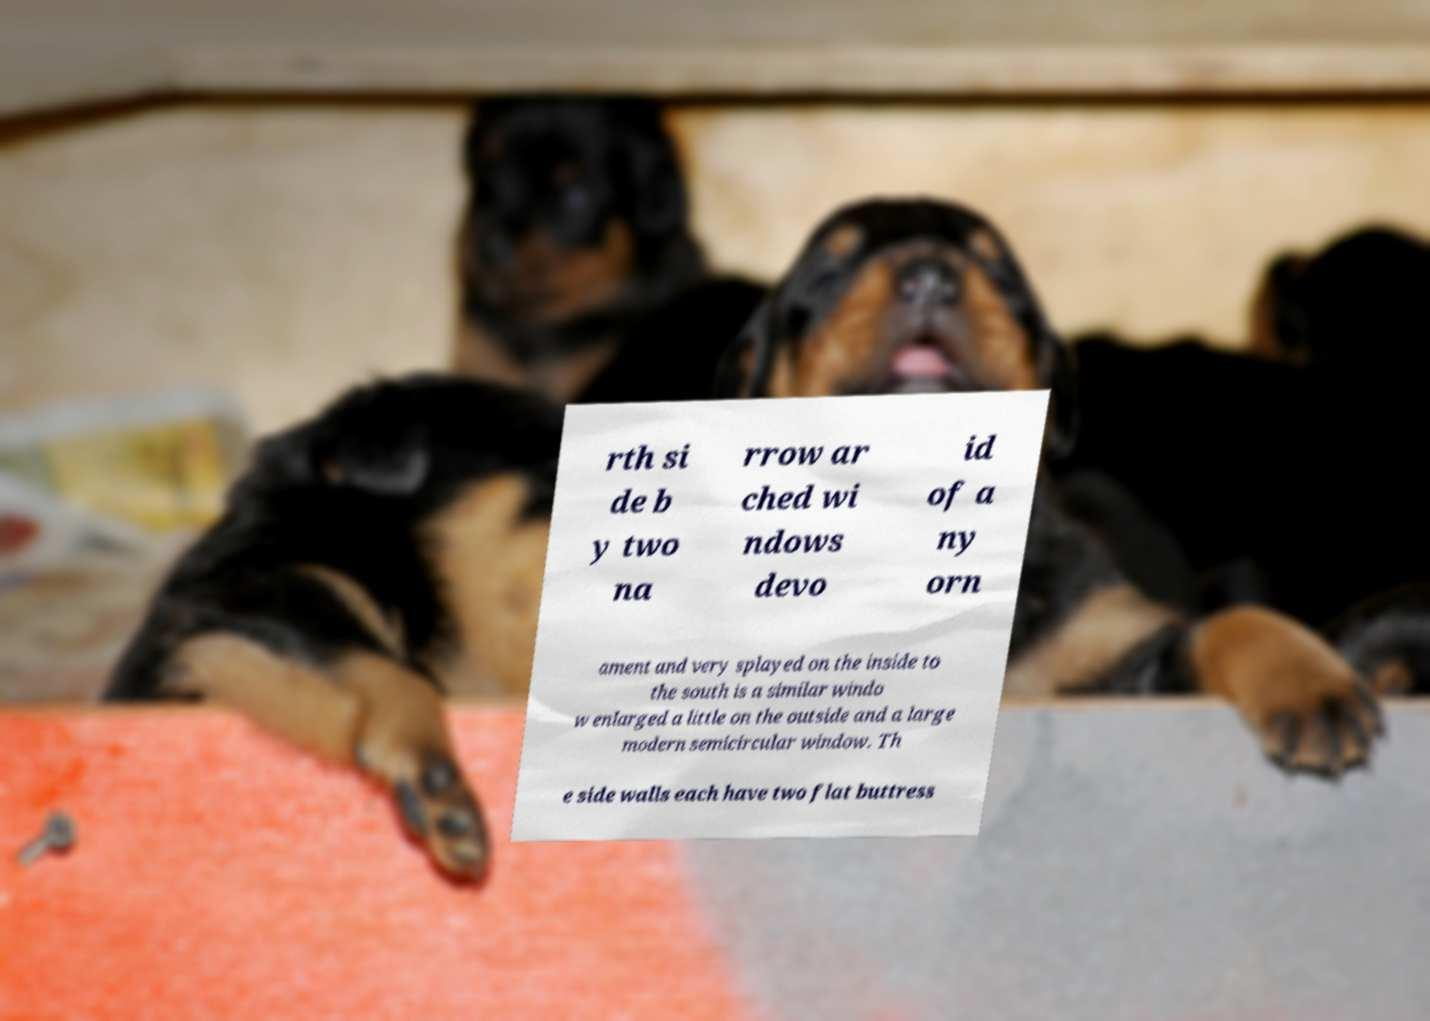I need the written content from this picture converted into text. Can you do that? rth si de b y two na rrow ar ched wi ndows devo id of a ny orn ament and very splayed on the inside to the south is a similar windo w enlarged a little on the outside and a large modern semicircular window. Th e side walls each have two flat buttress 